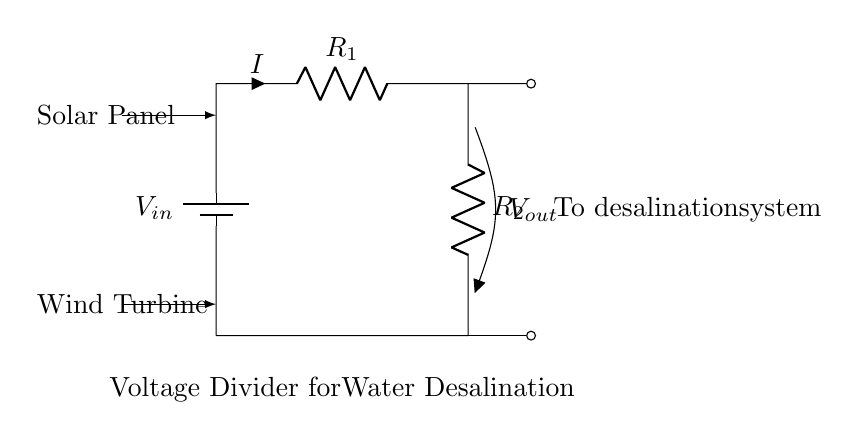What is the input voltage of the circuit? The input voltage of the circuit is represented by the symbol \( V_{in} \) which is depicted on the battery component in the diagram.
Answer: \( V_{in} \) What type of circuit is this? This is a voltage divider circuit, as indicated by the arrangement of the resistors and the purpose shown in the diagram.
Answer: Voltage Divider How many resistors are in the circuit? There are two resistors labeled \( R_1 \) and \( R_2 \) in the circuit, shown in series between the input and ground.
Answer: 2 What is the output voltage labeled as in the circuit? The output voltage is labeled \( V_{out} \), which is the voltage across the second resistor \( R_2 \) in the circuit.
Answer: \( V_{out} \) What is the direction of the current in the circuit? The current \( I \) flows from the positive terminal of the battery through \( R_1 \) and \( R_2 \) in a loop back to the negative terminal of the battery, as indicated by the arrow on \( I \).
Answer: Downward What happens to the output voltage if \( R_2 \) increases? If \( R_2 \) increases while keeping \( R_1 \) constant, the output voltage \( V_{out} \) will increase, since \( V_{out} \) is directly proportional to \( R_2 \) in a voltage divider configuration.
Answer: Increases Where does the output voltage connect in the diagram? The output voltage \( V_{out} \) connects to the desalination system as indicated by the label next to the output node in the circuit diagram.
Answer: Desalination system 